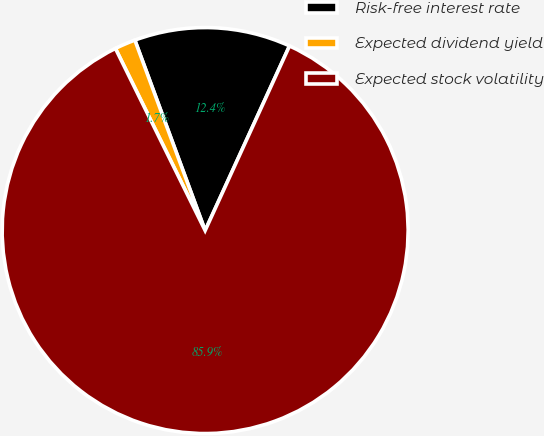<chart> <loc_0><loc_0><loc_500><loc_500><pie_chart><fcel>Risk-free interest rate<fcel>Expected dividend yield<fcel>Expected stock volatility<nl><fcel>12.45%<fcel>1.66%<fcel>85.89%<nl></chart> 